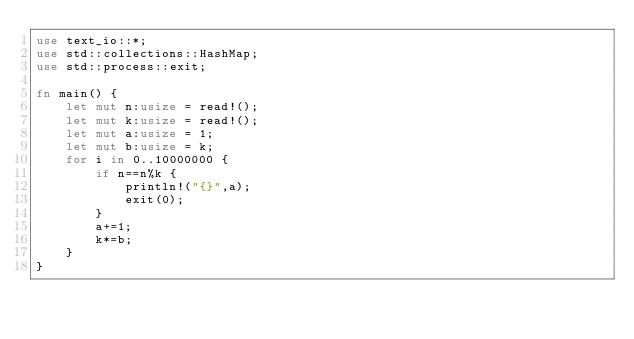<code> <loc_0><loc_0><loc_500><loc_500><_Rust_>use text_io::*;
use std::collections::HashMap;
use std::process::exit;

fn main() {
    let mut n:usize = read!();
    let mut k:usize = read!();
    let mut a:usize = 1;
    let mut b:usize = k;
    for i in 0..10000000 {
        if n==n%k {
            println!("{}",a);
            exit(0);
        }
        a+=1;
        k*=b;
    }
}</code> 